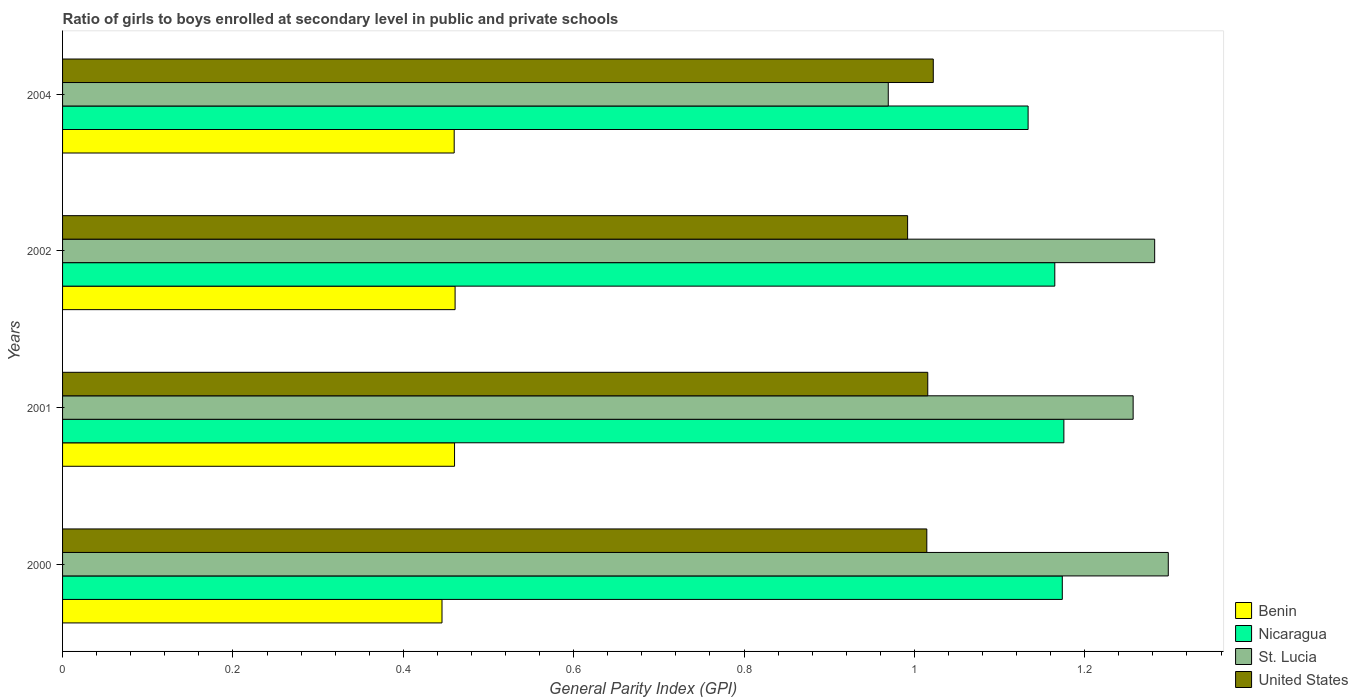How many groups of bars are there?
Your answer should be compact. 4. Are the number of bars on each tick of the Y-axis equal?
Provide a short and direct response. Yes. How many bars are there on the 3rd tick from the top?
Your answer should be compact. 4. How many bars are there on the 1st tick from the bottom?
Your response must be concise. 4. What is the label of the 4th group of bars from the top?
Keep it short and to the point. 2000. What is the general parity index in St. Lucia in 2000?
Make the answer very short. 1.3. Across all years, what is the maximum general parity index in St. Lucia?
Offer a terse response. 1.3. Across all years, what is the minimum general parity index in Benin?
Make the answer very short. 0.45. What is the total general parity index in United States in the graph?
Keep it short and to the point. 4.04. What is the difference between the general parity index in United States in 2002 and that in 2004?
Keep it short and to the point. -0.03. What is the difference between the general parity index in Benin in 2001 and the general parity index in United States in 2002?
Offer a very short reply. -0.53. What is the average general parity index in Nicaragua per year?
Your response must be concise. 1.16. In the year 2001, what is the difference between the general parity index in St. Lucia and general parity index in United States?
Your answer should be compact. 0.24. In how many years, is the general parity index in Benin greater than 1.2800000000000002 ?
Make the answer very short. 0. What is the ratio of the general parity index in United States in 2001 to that in 2002?
Provide a succinct answer. 1.02. Is the difference between the general parity index in St. Lucia in 2000 and 2002 greater than the difference between the general parity index in United States in 2000 and 2002?
Keep it short and to the point. No. What is the difference between the highest and the second highest general parity index in Benin?
Ensure brevity in your answer.  0. What is the difference between the highest and the lowest general parity index in Nicaragua?
Provide a succinct answer. 0.04. Is it the case that in every year, the sum of the general parity index in St. Lucia and general parity index in Benin is greater than the sum of general parity index in United States and general parity index in Nicaragua?
Your answer should be compact. No. What does the 4th bar from the top in 2001 represents?
Ensure brevity in your answer.  Benin. Is it the case that in every year, the sum of the general parity index in Nicaragua and general parity index in Benin is greater than the general parity index in St. Lucia?
Offer a terse response. Yes. Are all the bars in the graph horizontal?
Keep it short and to the point. Yes. Are the values on the major ticks of X-axis written in scientific E-notation?
Offer a terse response. No. Does the graph contain any zero values?
Ensure brevity in your answer.  No. How many legend labels are there?
Keep it short and to the point. 4. How are the legend labels stacked?
Provide a short and direct response. Vertical. What is the title of the graph?
Give a very brief answer. Ratio of girls to boys enrolled at secondary level in public and private schools. Does "Haiti" appear as one of the legend labels in the graph?
Your response must be concise. No. What is the label or title of the X-axis?
Provide a short and direct response. General Parity Index (GPI). What is the General Parity Index (GPI) in Benin in 2000?
Your response must be concise. 0.45. What is the General Parity Index (GPI) of Nicaragua in 2000?
Give a very brief answer. 1.17. What is the General Parity Index (GPI) in St. Lucia in 2000?
Your answer should be compact. 1.3. What is the General Parity Index (GPI) of United States in 2000?
Keep it short and to the point. 1.01. What is the General Parity Index (GPI) in Benin in 2001?
Offer a terse response. 0.46. What is the General Parity Index (GPI) in Nicaragua in 2001?
Offer a terse response. 1.18. What is the General Parity Index (GPI) of St. Lucia in 2001?
Your response must be concise. 1.26. What is the General Parity Index (GPI) of United States in 2001?
Provide a succinct answer. 1.02. What is the General Parity Index (GPI) in Benin in 2002?
Provide a succinct answer. 0.46. What is the General Parity Index (GPI) in Nicaragua in 2002?
Provide a succinct answer. 1.16. What is the General Parity Index (GPI) in St. Lucia in 2002?
Provide a short and direct response. 1.28. What is the General Parity Index (GPI) of United States in 2002?
Give a very brief answer. 0.99. What is the General Parity Index (GPI) in Benin in 2004?
Ensure brevity in your answer.  0.46. What is the General Parity Index (GPI) in Nicaragua in 2004?
Your answer should be compact. 1.13. What is the General Parity Index (GPI) of St. Lucia in 2004?
Your answer should be compact. 0.97. What is the General Parity Index (GPI) in United States in 2004?
Provide a succinct answer. 1.02. Across all years, what is the maximum General Parity Index (GPI) in Benin?
Give a very brief answer. 0.46. Across all years, what is the maximum General Parity Index (GPI) in Nicaragua?
Provide a succinct answer. 1.18. Across all years, what is the maximum General Parity Index (GPI) in St. Lucia?
Give a very brief answer. 1.3. Across all years, what is the maximum General Parity Index (GPI) in United States?
Offer a very short reply. 1.02. Across all years, what is the minimum General Parity Index (GPI) in Benin?
Make the answer very short. 0.45. Across all years, what is the minimum General Parity Index (GPI) in Nicaragua?
Make the answer very short. 1.13. Across all years, what is the minimum General Parity Index (GPI) in St. Lucia?
Offer a terse response. 0.97. Across all years, what is the minimum General Parity Index (GPI) of United States?
Offer a terse response. 0.99. What is the total General Parity Index (GPI) of Benin in the graph?
Ensure brevity in your answer.  1.83. What is the total General Parity Index (GPI) of Nicaragua in the graph?
Provide a short and direct response. 4.65. What is the total General Parity Index (GPI) of St. Lucia in the graph?
Offer a very short reply. 4.81. What is the total General Parity Index (GPI) in United States in the graph?
Provide a succinct answer. 4.04. What is the difference between the General Parity Index (GPI) of Benin in 2000 and that in 2001?
Your answer should be very brief. -0.01. What is the difference between the General Parity Index (GPI) in Nicaragua in 2000 and that in 2001?
Ensure brevity in your answer.  -0. What is the difference between the General Parity Index (GPI) of St. Lucia in 2000 and that in 2001?
Make the answer very short. 0.04. What is the difference between the General Parity Index (GPI) in United States in 2000 and that in 2001?
Keep it short and to the point. -0. What is the difference between the General Parity Index (GPI) in Benin in 2000 and that in 2002?
Your answer should be very brief. -0.02. What is the difference between the General Parity Index (GPI) of Nicaragua in 2000 and that in 2002?
Give a very brief answer. 0.01. What is the difference between the General Parity Index (GPI) of St. Lucia in 2000 and that in 2002?
Make the answer very short. 0.02. What is the difference between the General Parity Index (GPI) in United States in 2000 and that in 2002?
Offer a terse response. 0.02. What is the difference between the General Parity Index (GPI) of Benin in 2000 and that in 2004?
Offer a terse response. -0.01. What is the difference between the General Parity Index (GPI) of Nicaragua in 2000 and that in 2004?
Your response must be concise. 0.04. What is the difference between the General Parity Index (GPI) of St. Lucia in 2000 and that in 2004?
Ensure brevity in your answer.  0.33. What is the difference between the General Parity Index (GPI) in United States in 2000 and that in 2004?
Offer a very short reply. -0.01. What is the difference between the General Parity Index (GPI) of Benin in 2001 and that in 2002?
Your answer should be very brief. -0. What is the difference between the General Parity Index (GPI) in Nicaragua in 2001 and that in 2002?
Give a very brief answer. 0.01. What is the difference between the General Parity Index (GPI) in St. Lucia in 2001 and that in 2002?
Offer a terse response. -0.03. What is the difference between the General Parity Index (GPI) in United States in 2001 and that in 2002?
Your answer should be very brief. 0.02. What is the difference between the General Parity Index (GPI) of Nicaragua in 2001 and that in 2004?
Offer a terse response. 0.04. What is the difference between the General Parity Index (GPI) in St. Lucia in 2001 and that in 2004?
Your response must be concise. 0.29. What is the difference between the General Parity Index (GPI) of United States in 2001 and that in 2004?
Ensure brevity in your answer.  -0.01. What is the difference between the General Parity Index (GPI) of Benin in 2002 and that in 2004?
Keep it short and to the point. 0. What is the difference between the General Parity Index (GPI) of Nicaragua in 2002 and that in 2004?
Ensure brevity in your answer.  0.03. What is the difference between the General Parity Index (GPI) of St. Lucia in 2002 and that in 2004?
Your answer should be very brief. 0.31. What is the difference between the General Parity Index (GPI) of United States in 2002 and that in 2004?
Ensure brevity in your answer.  -0.03. What is the difference between the General Parity Index (GPI) of Benin in 2000 and the General Parity Index (GPI) of Nicaragua in 2001?
Give a very brief answer. -0.73. What is the difference between the General Parity Index (GPI) of Benin in 2000 and the General Parity Index (GPI) of St. Lucia in 2001?
Offer a terse response. -0.81. What is the difference between the General Parity Index (GPI) in Benin in 2000 and the General Parity Index (GPI) in United States in 2001?
Give a very brief answer. -0.57. What is the difference between the General Parity Index (GPI) of Nicaragua in 2000 and the General Parity Index (GPI) of St. Lucia in 2001?
Offer a very short reply. -0.08. What is the difference between the General Parity Index (GPI) in Nicaragua in 2000 and the General Parity Index (GPI) in United States in 2001?
Keep it short and to the point. 0.16. What is the difference between the General Parity Index (GPI) of St. Lucia in 2000 and the General Parity Index (GPI) of United States in 2001?
Provide a succinct answer. 0.28. What is the difference between the General Parity Index (GPI) of Benin in 2000 and the General Parity Index (GPI) of Nicaragua in 2002?
Keep it short and to the point. -0.72. What is the difference between the General Parity Index (GPI) in Benin in 2000 and the General Parity Index (GPI) in St. Lucia in 2002?
Make the answer very short. -0.84. What is the difference between the General Parity Index (GPI) of Benin in 2000 and the General Parity Index (GPI) of United States in 2002?
Provide a succinct answer. -0.55. What is the difference between the General Parity Index (GPI) of Nicaragua in 2000 and the General Parity Index (GPI) of St. Lucia in 2002?
Provide a short and direct response. -0.11. What is the difference between the General Parity Index (GPI) in Nicaragua in 2000 and the General Parity Index (GPI) in United States in 2002?
Provide a short and direct response. 0.18. What is the difference between the General Parity Index (GPI) of St. Lucia in 2000 and the General Parity Index (GPI) of United States in 2002?
Your answer should be very brief. 0.31. What is the difference between the General Parity Index (GPI) in Benin in 2000 and the General Parity Index (GPI) in Nicaragua in 2004?
Your answer should be very brief. -0.69. What is the difference between the General Parity Index (GPI) in Benin in 2000 and the General Parity Index (GPI) in St. Lucia in 2004?
Make the answer very short. -0.52. What is the difference between the General Parity Index (GPI) of Benin in 2000 and the General Parity Index (GPI) of United States in 2004?
Offer a terse response. -0.58. What is the difference between the General Parity Index (GPI) of Nicaragua in 2000 and the General Parity Index (GPI) of St. Lucia in 2004?
Offer a very short reply. 0.2. What is the difference between the General Parity Index (GPI) of Nicaragua in 2000 and the General Parity Index (GPI) of United States in 2004?
Ensure brevity in your answer.  0.15. What is the difference between the General Parity Index (GPI) in St. Lucia in 2000 and the General Parity Index (GPI) in United States in 2004?
Provide a short and direct response. 0.28. What is the difference between the General Parity Index (GPI) of Benin in 2001 and the General Parity Index (GPI) of Nicaragua in 2002?
Make the answer very short. -0.7. What is the difference between the General Parity Index (GPI) of Benin in 2001 and the General Parity Index (GPI) of St. Lucia in 2002?
Give a very brief answer. -0.82. What is the difference between the General Parity Index (GPI) in Benin in 2001 and the General Parity Index (GPI) in United States in 2002?
Your response must be concise. -0.53. What is the difference between the General Parity Index (GPI) in Nicaragua in 2001 and the General Parity Index (GPI) in St. Lucia in 2002?
Ensure brevity in your answer.  -0.11. What is the difference between the General Parity Index (GPI) of Nicaragua in 2001 and the General Parity Index (GPI) of United States in 2002?
Your answer should be compact. 0.18. What is the difference between the General Parity Index (GPI) in St. Lucia in 2001 and the General Parity Index (GPI) in United States in 2002?
Make the answer very short. 0.26. What is the difference between the General Parity Index (GPI) of Benin in 2001 and the General Parity Index (GPI) of Nicaragua in 2004?
Give a very brief answer. -0.67. What is the difference between the General Parity Index (GPI) in Benin in 2001 and the General Parity Index (GPI) in St. Lucia in 2004?
Your answer should be compact. -0.51. What is the difference between the General Parity Index (GPI) of Benin in 2001 and the General Parity Index (GPI) of United States in 2004?
Offer a terse response. -0.56. What is the difference between the General Parity Index (GPI) in Nicaragua in 2001 and the General Parity Index (GPI) in St. Lucia in 2004?
Provide a succinct answer. 0.21. What is the difference between the General Parity Index (GPI) of Nicaragua in 2001 and the General Parity Index (GPI) of United States in 2004?
Offer a very short reply. 0.15. What is the difference between the General Parity Index (GPI) of St. Lucia in 2001 and the General Parity Index (GPI) of United States in 2004?
Give a very brief answer. 0.23. What is the difference between the General Parity Index (GPI) in Benin in 2002 and the General Parity Index (GPI) in Nicaragua in 2004?
Your response must be concise. -0.67. What is the difference between the General Parity Index (GPI) of Benin in 2002 and the General Parity Index (GPI) of St. Lucia in 2004?
Provide a short and direct response. -0.51. What is the difference between the General Parity Index (GPI) of Benin in 2002 and the General Parity Index (GPI) of United States in 2004?
Ensure brevity in your answer.  -0.56. What is the difference between the General Parity Index (GPI) of Nicaragua in 2002 and the General Parity Index (GPI) of St. Lucia in 2004?
Your response must be concise. 0.2. What is the difference between the General Parity Index (GPI) in Nicaragua in 2002 and the General Parity Index (GPI) in United States in 2004?
Give a very brief answer. 0.14. What is the difference between the General Parity Index (GPI) in St. Lucia in 2002 and the General Parity Index (GPI) in United States in 2004?
Provide a short and direct response. 0.26. What is the average General Parity Index (GPI) of Benin per year?
Provide a succinct answer. 0.46. What is the average General Parity Index (GPI) of Nicaragua per year?
Keep it short and to the point. 1.16. What is the average General Parity Index (GPI) in St. Lucia per year?
Offer a very short reply. 1.2. What is the average General Parity Index (GPI) in United States per year?
Keep it short and to the point. 1.01. In the year 2000, what is the difference between the General Parity Index (GPI) of Benin and General Parity Index (GPI) of Nicaragua?
Provide a succinct answer. -0.73. In the year 2000, what is the difference between the General Parity Index (GPI) in Benin and General Parity Index (GPI) in St. Lucia?
Make the answer very short. -0.85. In the year 2000, what is the difference between the General Parity Index (GPI) of Benin and General Parity Index (GPI) of United States?
Offer a very short reply. -0.57. In the year 2000, what is the difference between the General Parity Index (GPI) of Nicaragua and General Parity Index (GPI) of St. Lucia?
Give a very brief answer. -0.12. In the year 2000, what is the difference between the General Parity Index (GPI) in Nicaragua and General Parity Index (GPI) in United States?
Ensure brevity in your answer.  0.16. In the year 2000, what is the difference between the General Parity Index (GPI) in St. Lucia and General Parity Index (GPI) in United States?
Keep it short and to the point. 0.28. In the year 2001, what is the difference between the General Parity Index (GPI) in Benin and General Parity Index (GPI) in Nicaragua?
Offer a very short reply. -0.72. In the year 2001, what is the difference between the General Parity Index (GPI) in Benin and General Parity Index (GPI) in St. Lucia?
Ensure brevity in your answer.  -0.8. In the year 2001, what is the difference between the General Parity Index (GPI) in Benin and General Parity Index (GPI) in United States?
Offer a very short reply. -0.56. In the year 2001, what is the difference between the General Parity Index (GPI) of Nicaragua and General Parity Index (GPI) of St. Lucia?
Give a very brief answer. -0.08. In the year 2001, what is the difference between the General Parity Index (GPI) in Nicaragua and General Parity Index (GPI) in United States?
Your answer should be very brief. 0.16. In the year 2001, what is the difference between the General Parity Index (GPI) in St. Lucia and General Parity Index (GPI) in United States?
Your answer should be compact. 0.24. In the year 2002, what is the difference between the General Parity Index (GPI) in Benin and General Parity Index (GPI) in Nicaragua?
Your response must be concise. -0.7. In the year 2002, what is the difference between the General Parity Index (GPI) of Benin and General Parity Index (GPI) of St. Lucia?
Ensure brevity in your answer.  -0.82. In the year 2002, what is the difference between the General Parity Index (GPI) in Benin and General Parity Index (GPI) in United States?
Your answer should be very brief. -0.53. In the year 2002, what is the difference between the General Parity Index (GPI) of Nicaragua and General Parity Index (GPI) of St. Lucia?
Your answer should be compact. -0.12. In the year 2002, what is the difference between the General Parity Index (GPI) in Nicaragua and General Parity Index (GPI) in United States?
Your response must be concise. 0.17. In the year 2002, what is the difference between the General Parity Index (GPI) in St. Lucia and General Parity Index (GPI) in United States?
Your answer should be compact. 0.29. In the year 2004, what is the difference between the General Parity Index (GPI) of Benin and General Parity Index (GPI) of Nicaragua?
Provide a short and direct response. -0.67. In the year 2004, what is the difference between the General Parity Index (GPI) of Benin and General Parity Index (GPI) of St. Lucia?
Make the answer very short. -0.51. In the year 2004, what is the difference between the General Parity Index (GPI) in Benin and General Parity Index (GPI) in United States?
Offer a very short reply. -0.56. In the year 2004, what is the difference between the General Parity Index (GPI) in Nicaragua and General Parity Index (GPI) in St. Lucia?
Keep it short and to the point. 0.16. In the year 2004, what is the difference between the General Parity Index (GPI) in Nicaragua and General Parity Index (GPI) in United States?
Ensure brevity in your answer.  0.11. In the year 2004, what is the difference between the General Parity Index (GPI) in St. Lucia and General Parity Index (GPI) in United States?
Offer a very short reply. -0.05. What is the ratio of the General Parity Index (GPI) of Benin in 2000 to that in 2001?
Provide a succinct answer. 0.97. What is the ratio of the General Parity Index (GPI) in Nicaragua in 2000 to that in 2001?
Provide a short and direct response. 1. What is the ratio of the General Parity Index (GPI) in St. Lucia in 2000 to that in 2001?
Give a very brief answer. 1.03. What is the ratio of the General Parity Index (GPI) in Benin in 2000 to that in 2002?
Your answer should be very brief. 0.97. What is the ratio of the General Parity Index (GPI) of Nicaragua in 2000 to that in 2002?
Offer a terse response. 1.01. What is the ratio of the General Parity Index (GPI) of St. Lucia in 2000 to that in 2002?
Your response must be concise. 1.01. What is the ratio of the General Parity Index (GPI) in United States in 2000 to that in 2002?
Offer a very short reply. 1.02. What is the ratio of the General Parity Index (GPI) of Benin in 2000 to that in 2004?
Provide a succinct answer. 0.97. What is the ratio of the General Parity Index (GPI) in Nicaragua in 2000 to that in 2004?
Ensure brevity in your answer.  1.04. What is the ratio of the General Parity Index (GPI) of St. Lucia in 2000 to that in 2004?
Ensure brevity in your answer.  1.34. What is the ratio of the General Parity Index (GPI) in United States in 2000 to that in 2004?
Your answer should be very brief. 0.99. What is the ratio of the General Parity Index (GPI) in Nicaragua in 2001 to that in 2002?
Your response must be concise. 1.01. What is the ratio of the General Parity Index (GPI) of St. Lucia in 2001 to that in 2002?
Ensure brevity in your answer.  0.98. What is the ratio of the General Parity Index (GPI) in United States in 2001 to that in 2002?
Provide a short and direct response. 1.02. What is the ratio of the General Parity Index (GPI) of Benin in 2001 to that in 2004?
Offer a very short reply. 1. What is the ratio of the General Parity Index (GPI) of Nicaragua in 2001 to that in 2004?
Provide a short and direct response. 1.04. What is the ratio of the General Parity Index (GPI) of St. Lucia in 2001 to that in 2004?
Your answer should be very brief. 1.3. What is the ratio of the General Parity Index (GPI) in Nicaragua in 2002 to that in 2004?
Offer a very short reply. 1.03. What is the ratio of the General Parity Index (GPI) of St. Lucia in 2002 to that in 2004?
Provide a short and direct response. 1.32. What is the ratio of the General Parity Index (GPI) of United States in 2002 to that in 2004?
Provide a short and direct response. 0.97. What is the difference between the highest and the second highest General Parity Index (GPI) of Benin?
Your answer should be compact. 0. What is the difference between the highest and the second highest General Parity Index (GPI) in Nicaragua?
Give a very brief answer. 0. What is the difference between the highest and the second highest General Parity Index (GPI) of St. Lucia?
Your answer should be compact. 0.02. What is the difference between the highest and the second highest General Parity Index (GPI) in United States?
Provide a short and direct response. 0.01. What is the difference between the highest and the lowest General Parity Index (GPI) in Benin?
Keep it short and to the point. 0.02. What is the difference between the highest and the lowest General Parity Index (GPI) of Nicaragua?
Provide a succinct answer. 0.04. What is the difference between the highest and the lowest General Parity Index (GPI) of St. Lucia?
Offer a very short reply. 0.33. What is the difference between the highest and the lowest General Parity Index (GPI) of United States?
Make the answer very short. 0.03. 